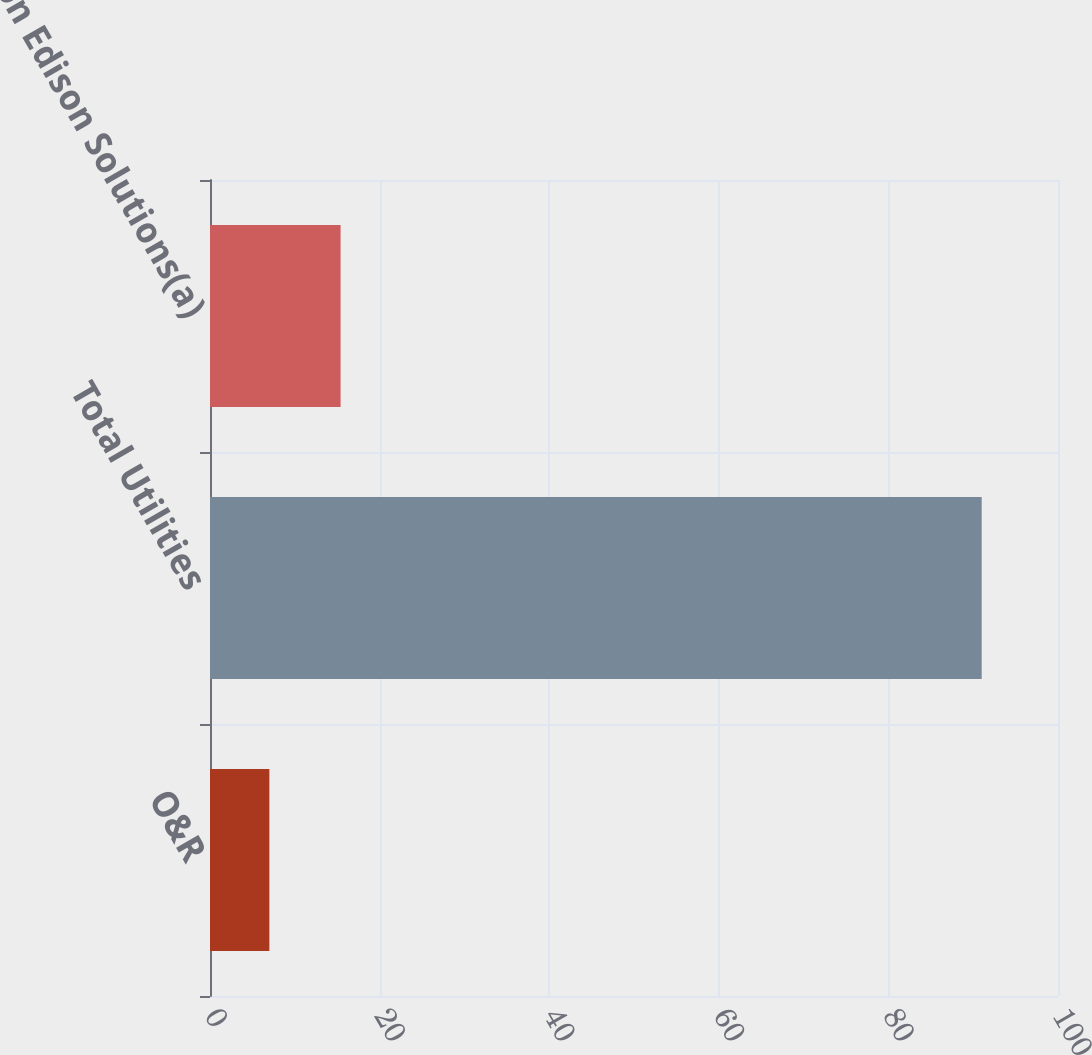Convert chart. <chart><loc_0><loc_0><loc_500><loc_500><bar_chart><fcel>O&R<fcel>Total Utilities<fcel>Con Edison Solutions(a)<nl><fcel>7<fcel>91<fcel>15.4<nl></chart> 